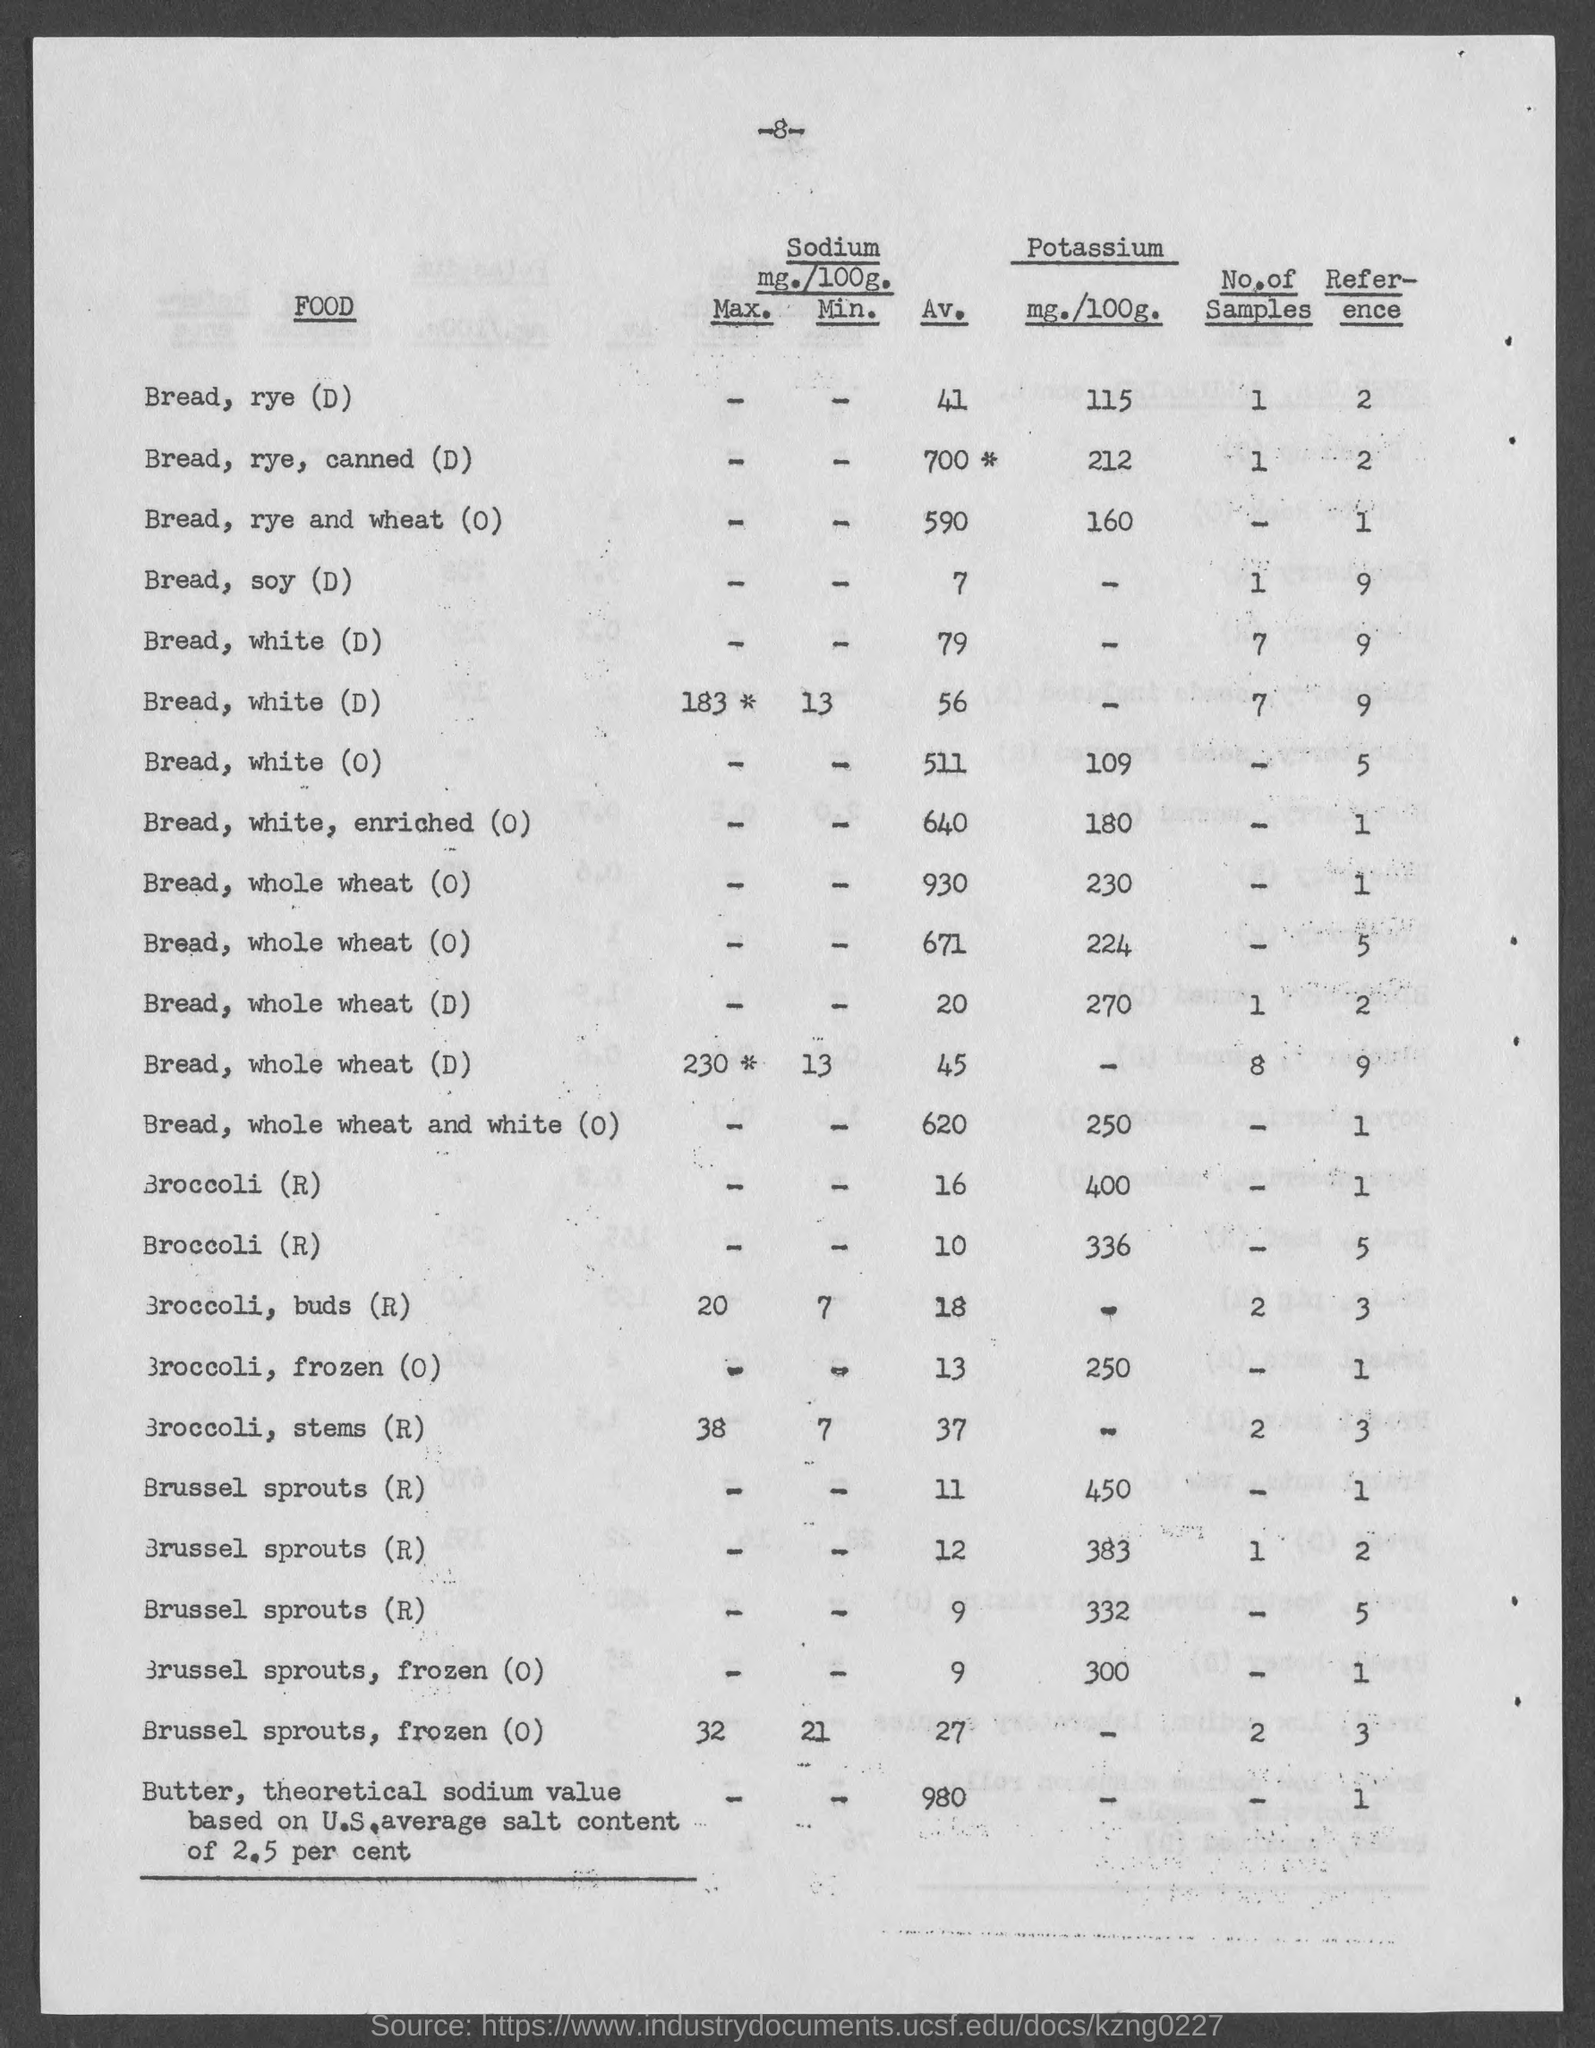Give some essential details in this illustration. The average sodium content in bread, soy (D) is 7 milligrams per serving. The amount of Potassium in a serving of frozen broccoli is 250 mg. The average sodium content in bread made from rye and wheat is 590 mg per serving, which is a relatively low amount compared to other types of bread. The average sodium content in broccoli buds is 18 milligrams per serving. The average amount of sodium in a serving of white, enriched bread is 640 milligrams. 